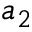Convert formula to latex. <formula><loc_0><loc_0><loc_500><loc_500>a _ { 2 }</formula> 